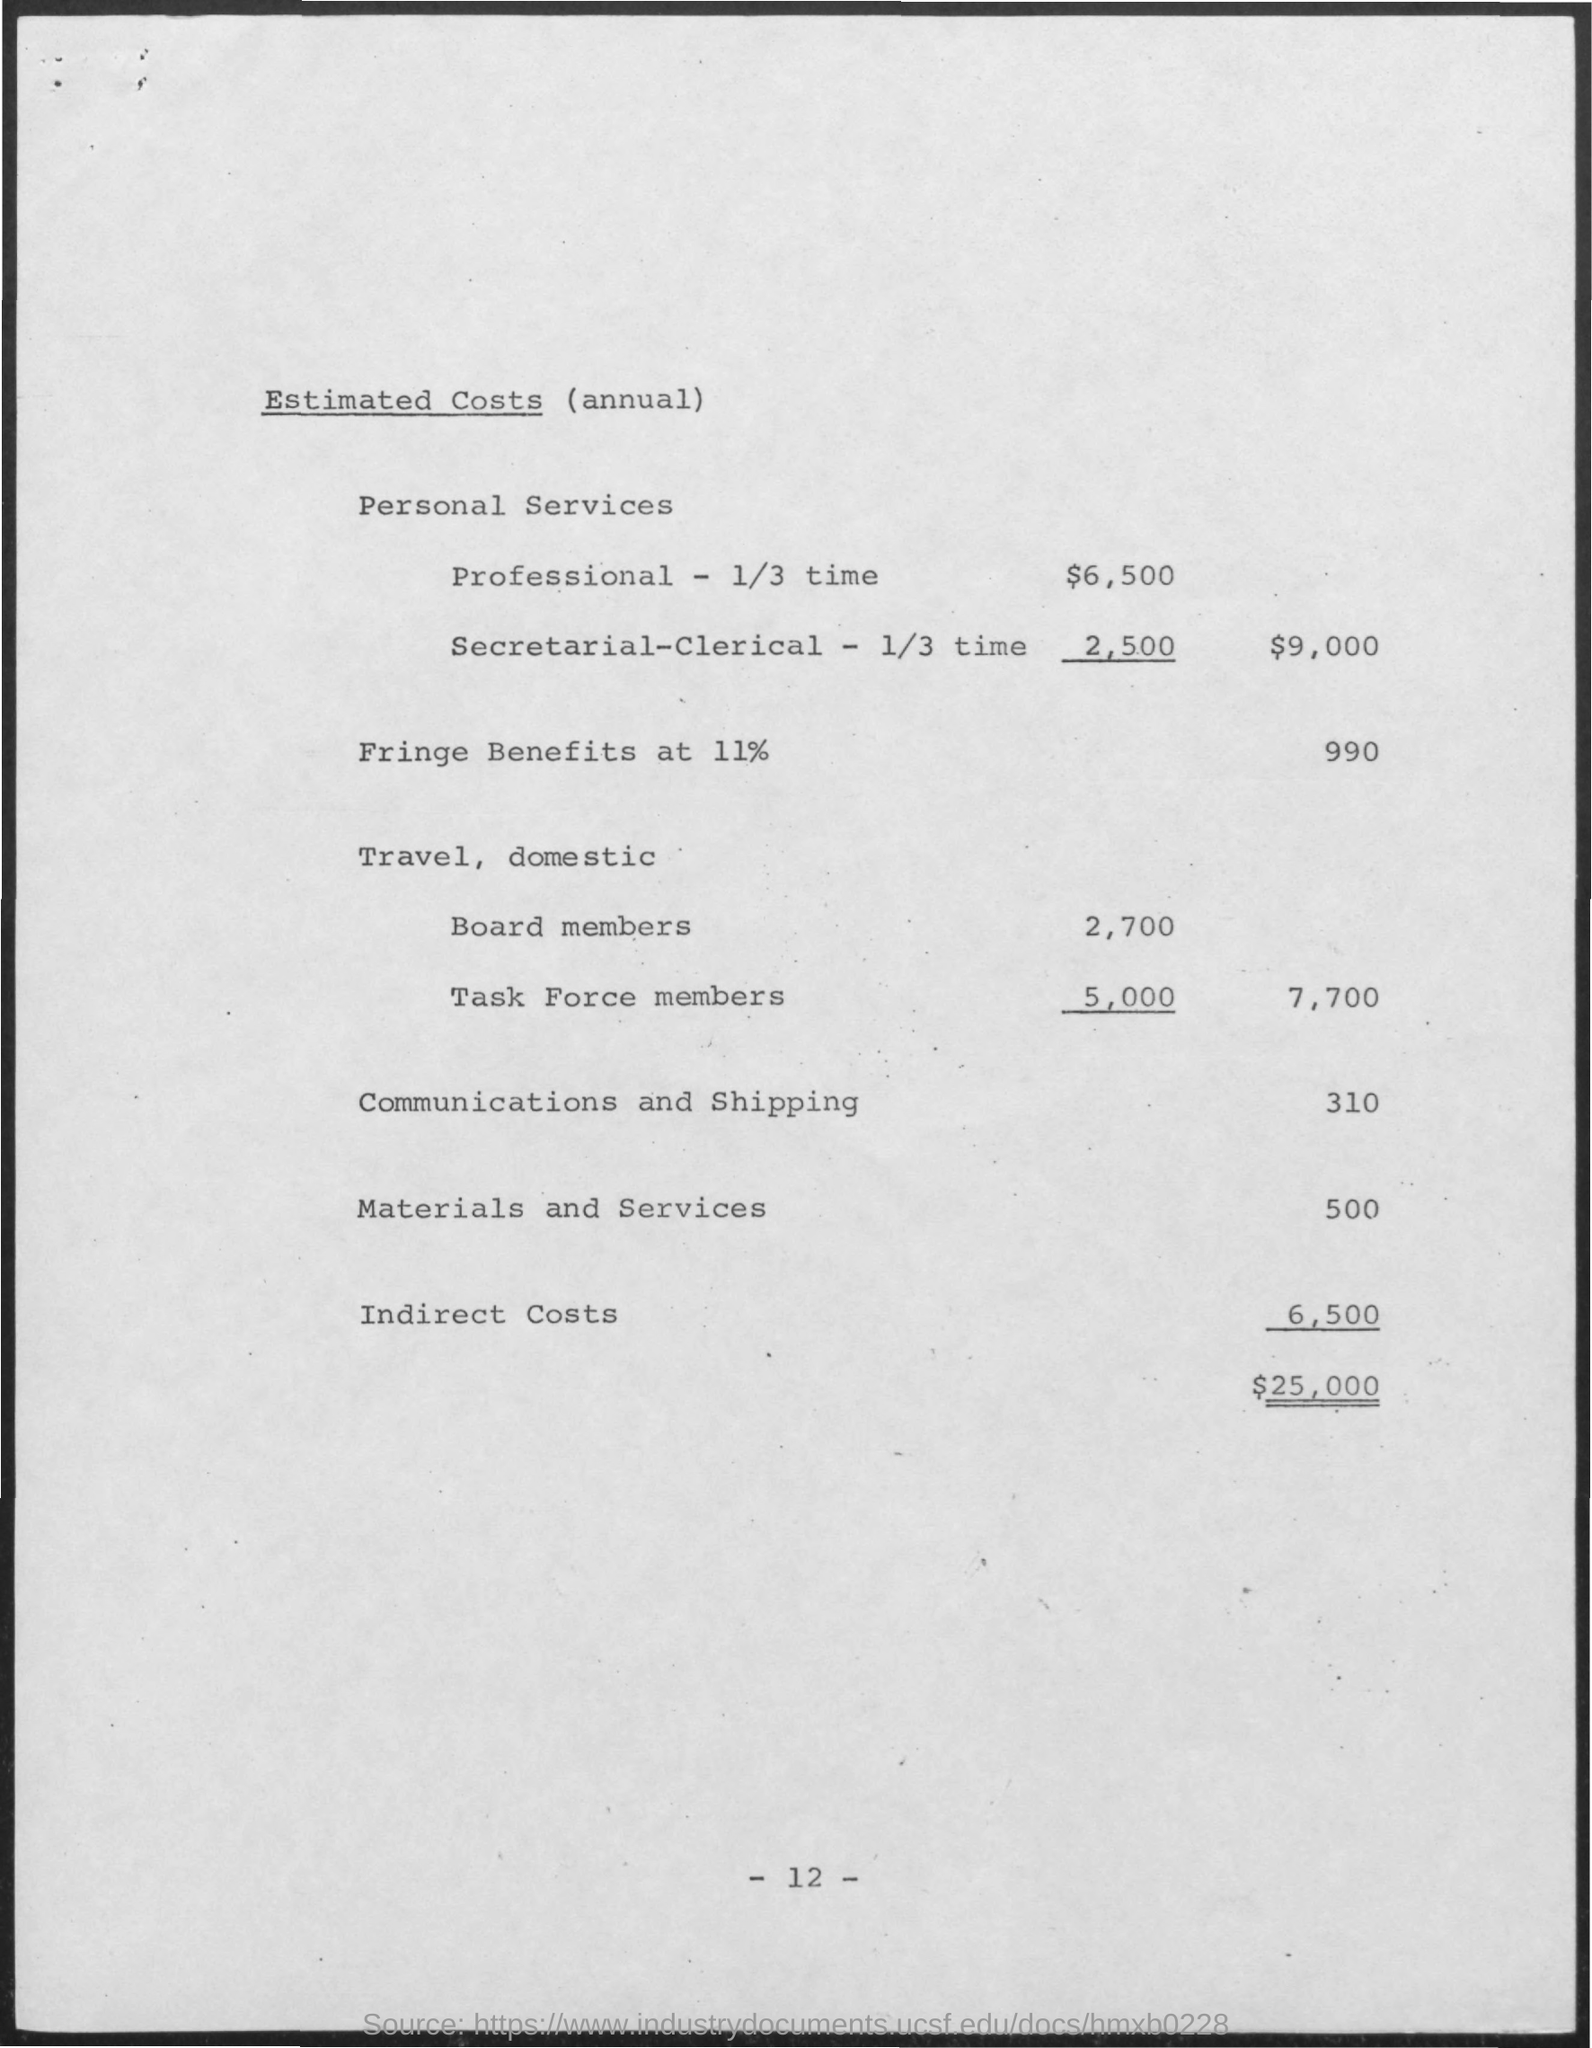What is the estimated costs of materials and services mentioned ?
Offer a terse response. 500. What is the estimated costs of communications and shipping mentioned ?
Provide a succinct answer. 310. What is the estimated costs of indirect costs mentioned ?
Provide a short and direct response. 6,500. What is the estimated costs of fringe benefits at 11% ?
Your answer should be compact. 990. 